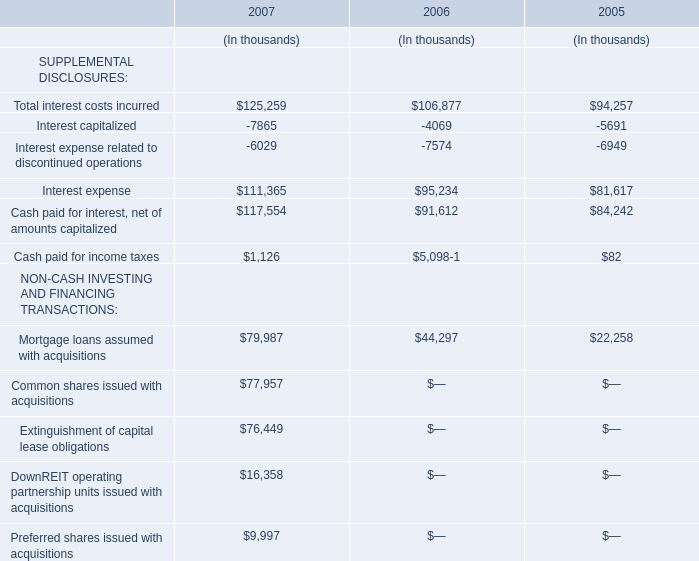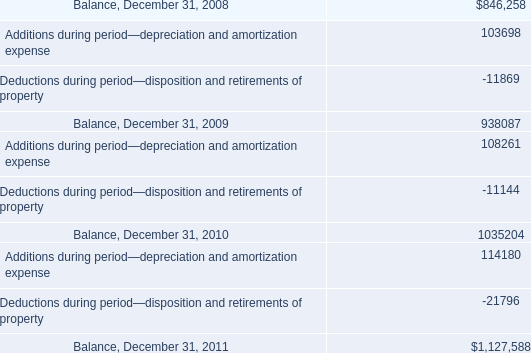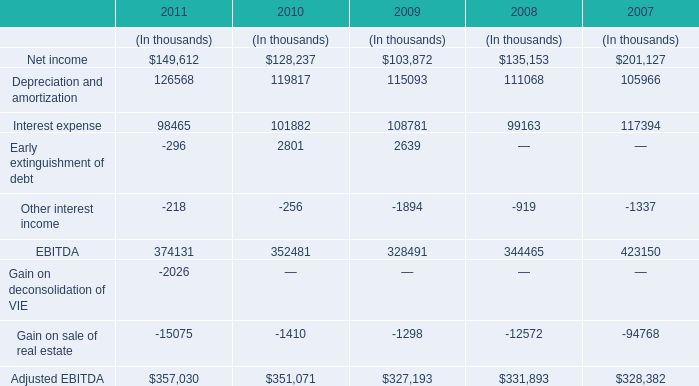What is the sum of Net income, Depreciation and amortization and Interest expense in 2011? (in thousand) 
Computations: ((149612 + 126568) + 98465)
Answer: 374645.0. 